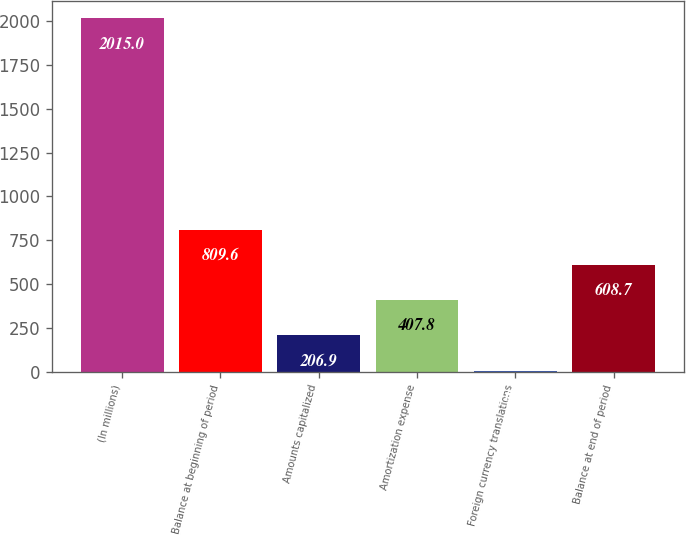<chart> <loc_0><loc_0><loc_500><loc_500><bar_chart><fcel>(In millions)<fcel>Balance at beginning of period<fcel>Amounts capitalized<fcel>Amortization expense<fcel>Foreign currency translations<fcel>Balance at end of period<nl><fcel>2015<fcel>809.6<fcel>206.9<fcel>407.8<fcel>6<fcel>608.7<nl></chart> 